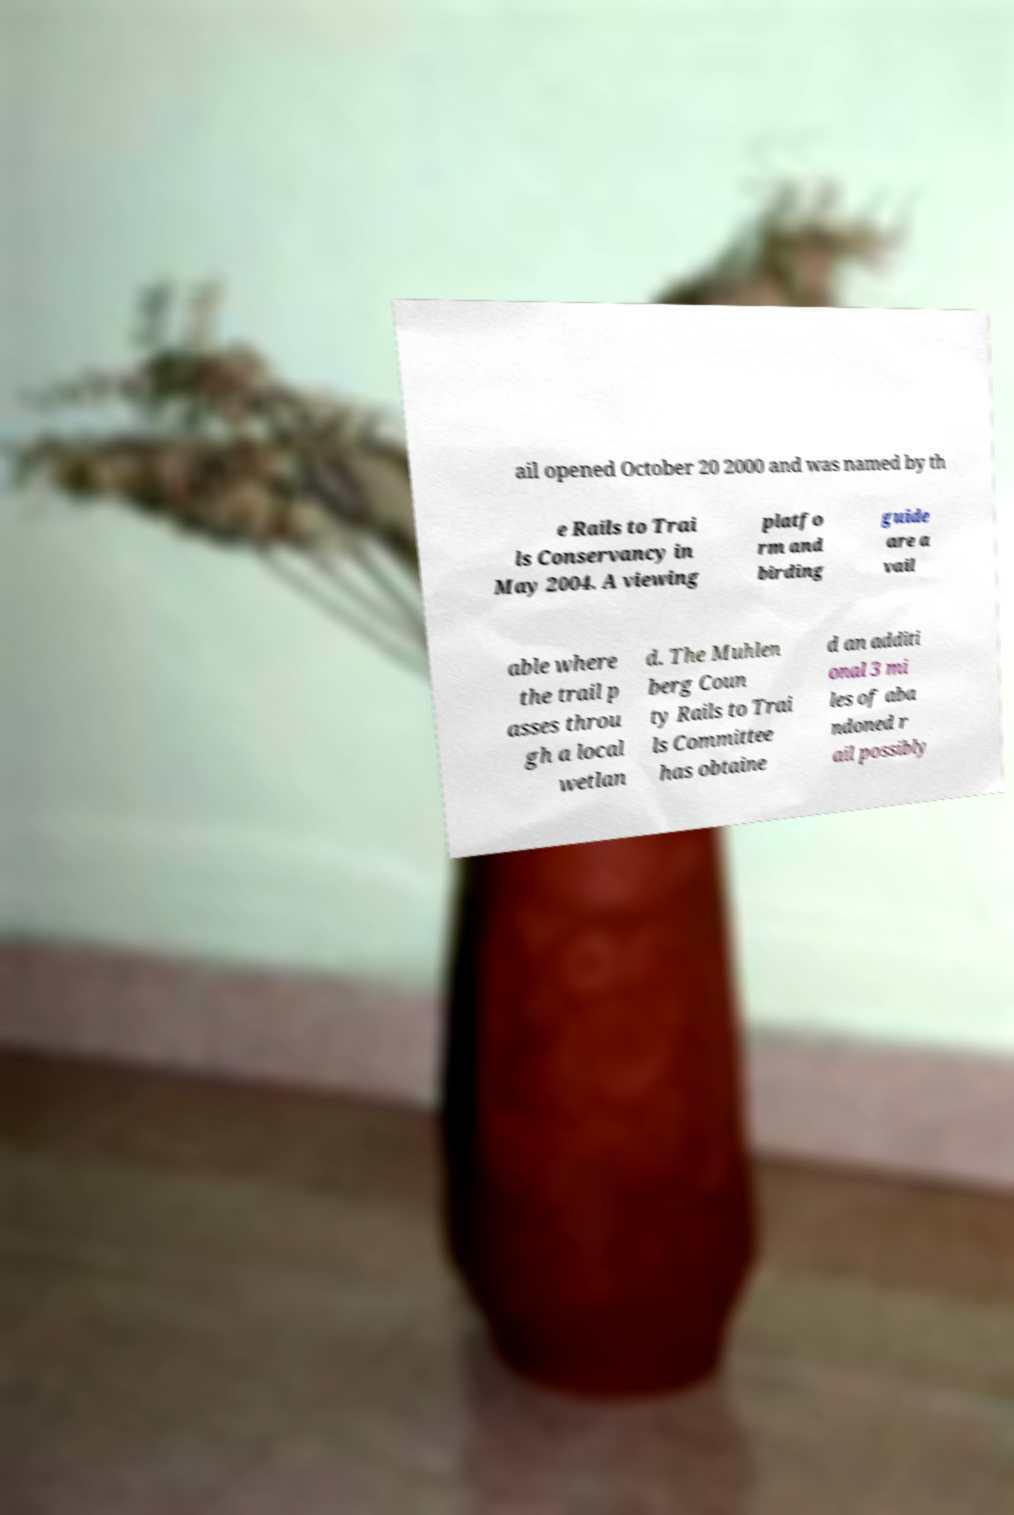Can you read and provide the text displayed in the image?This photo seems to have some interesting text. Can you extract and type it out for me? ail opened October 20 2000 and was named by th e Rails to Trai ls Conservancy in May 2004. A viewing platfo rm and birding guide are a vail able where the trail p asses throu gh a local wetlan d. The Muhlen berg Coun ty Rails to Trai ls Committee has obtaine d an additi onal 3 mi les of aba ndoned r ail possibly 